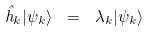Convert formula to latex. <formula><loc_0><loc_0><loc_500><loc_500>\hat { h } _ { k } | \psi _ { k } \rangle \ = \ \lambda _ { k } | \psi _ { k } \rangle</formula> 